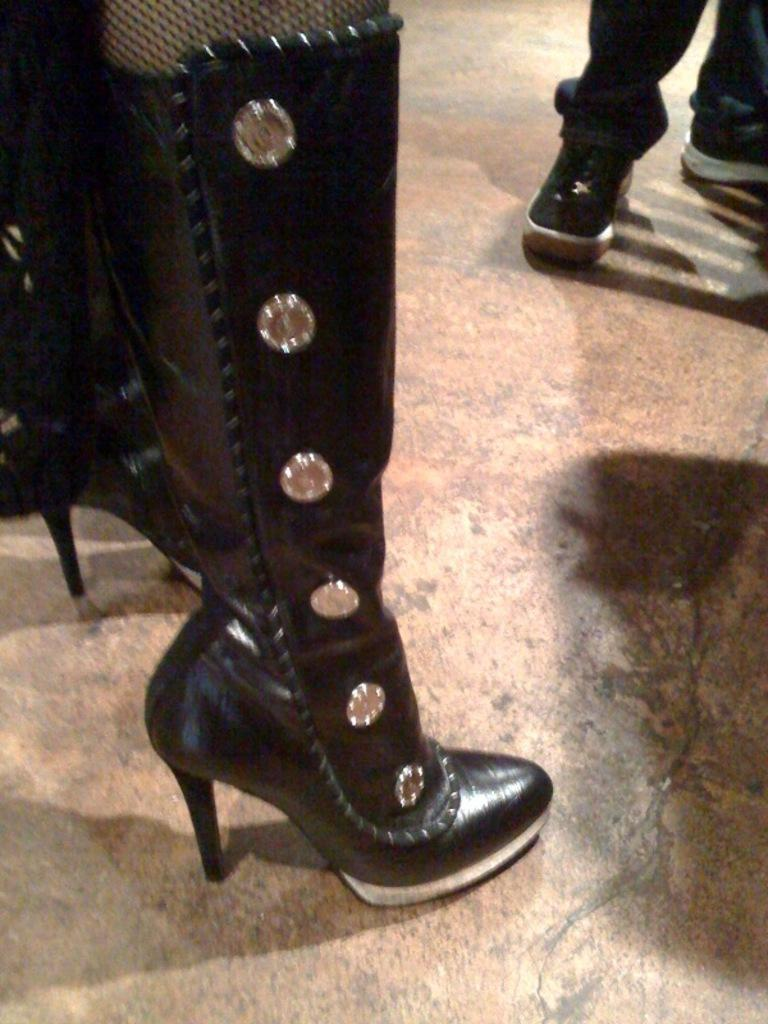What type of footwear is visible in the image? There is a black shoe in the image. Can you describe the person in the background of the image? The person in the background is wearing black pants and black shoes. Is the person holding an umbrella in the image? There is no mention of an umbrella in the image, so it cannot be determined if the person is holding one. 